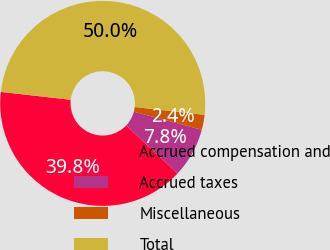<chart> <loc_0><loc_0><loc_500><loc_500><pie_chart><fcel>Accrued compensation and<fcel>Accrued taxes<fcel>Miscellaneous<fcel>Total<nl><fcel>39.8%<fcel>7.84%<fcel>2.36%<fcel>50.0%<nl></chart> 